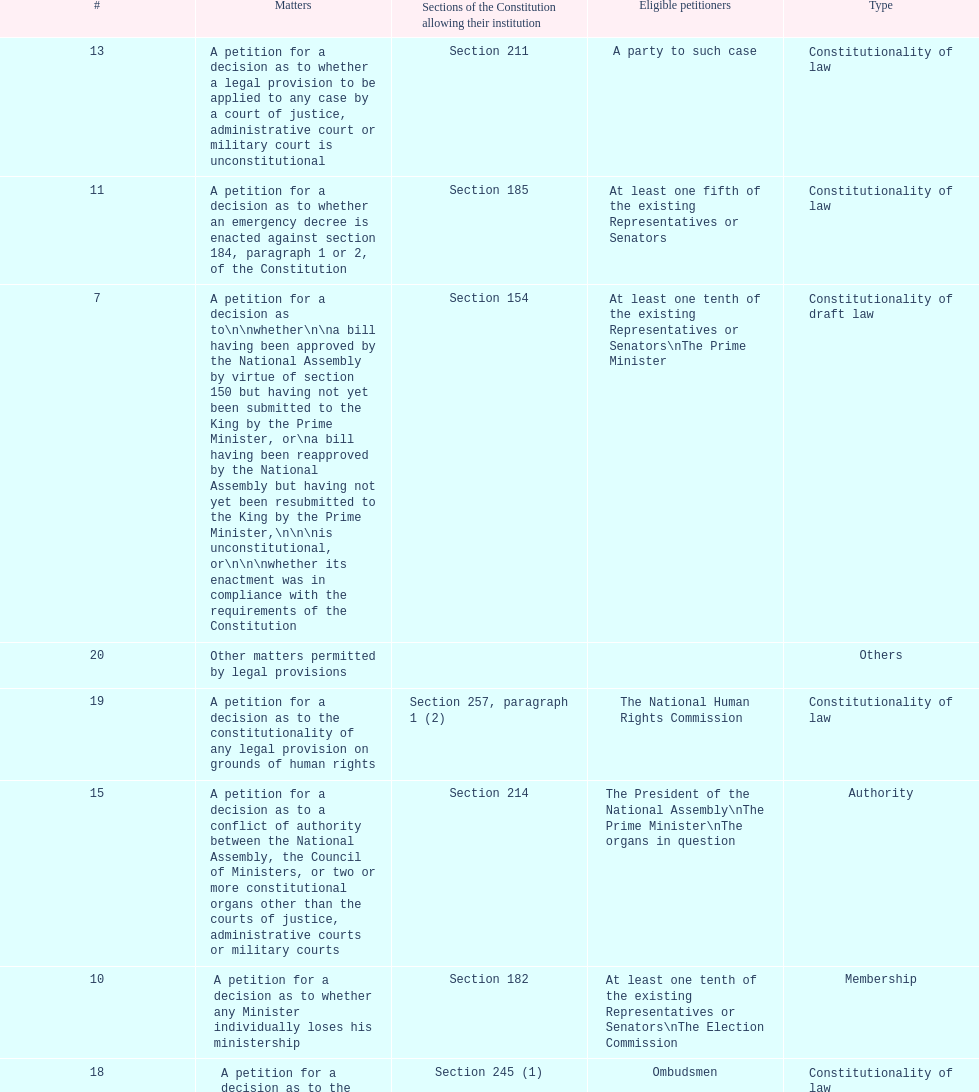Any person can petition matters 2 and 17. true or false? True. 